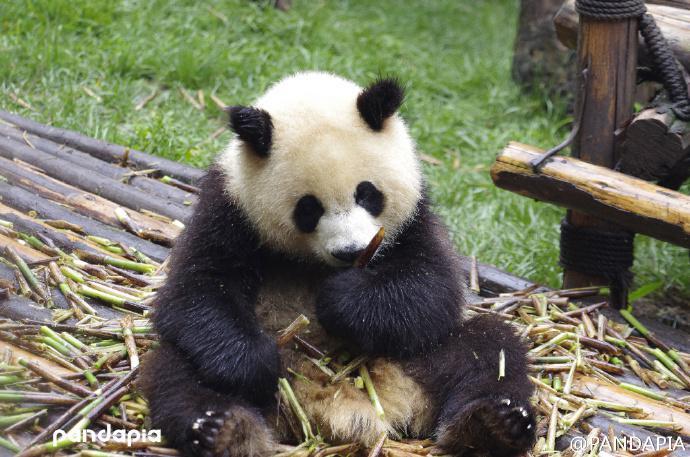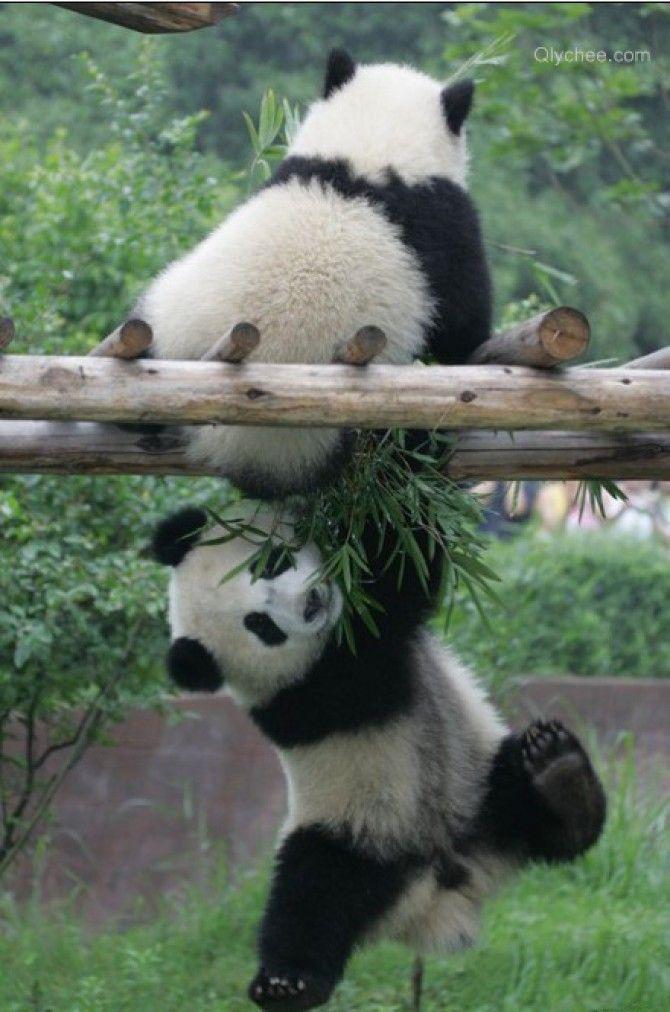The first image is the image on the left, the second image is the image on the right. Evaluate the accuracy of this statement regarding the images: "The panda in the image on the left is sitting near an upright post.". Is it true? Answer yes or no. Yes. The first image is the image on the left, the second image is the image on the right. Given the left and right images, does the statement "The panda on the left is looking toward the camera and holding a roundish-shaped food near its mouth." hold true? Answer yes or no. No. 